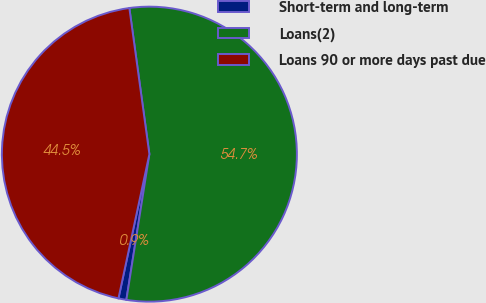Convert chart. <chart><loc_0><loc_0><loc_500><loc_500><pie_chart><fcel>Short-term and long-term<fcel>Loans(2)<fcel>Loans 90 or more days past due<nl><fcel>0.87%<fcel>54.66%<fcel>44.47%<nl></chart> 